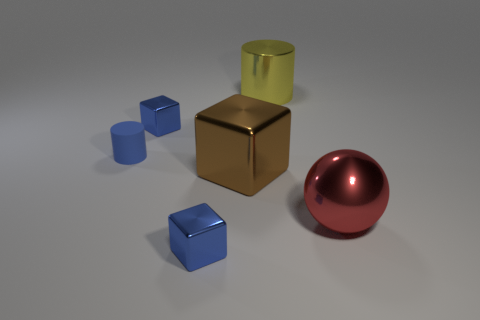Add 4 tiny red shiny balls. How many objects exist? 10 Subtract all cylinders. How many objects are left? 4 Add 2 blue shiny cubes. How many blue shiny cubes exist? 4 Subtract 0 yellow blocks. How many objects are left? 6 Subtract all tiny metallic things. Subtract all brown cubes. How many objects are left? 3 Add 6 brown metal cubes. How many brown metal cubes are left? 7 